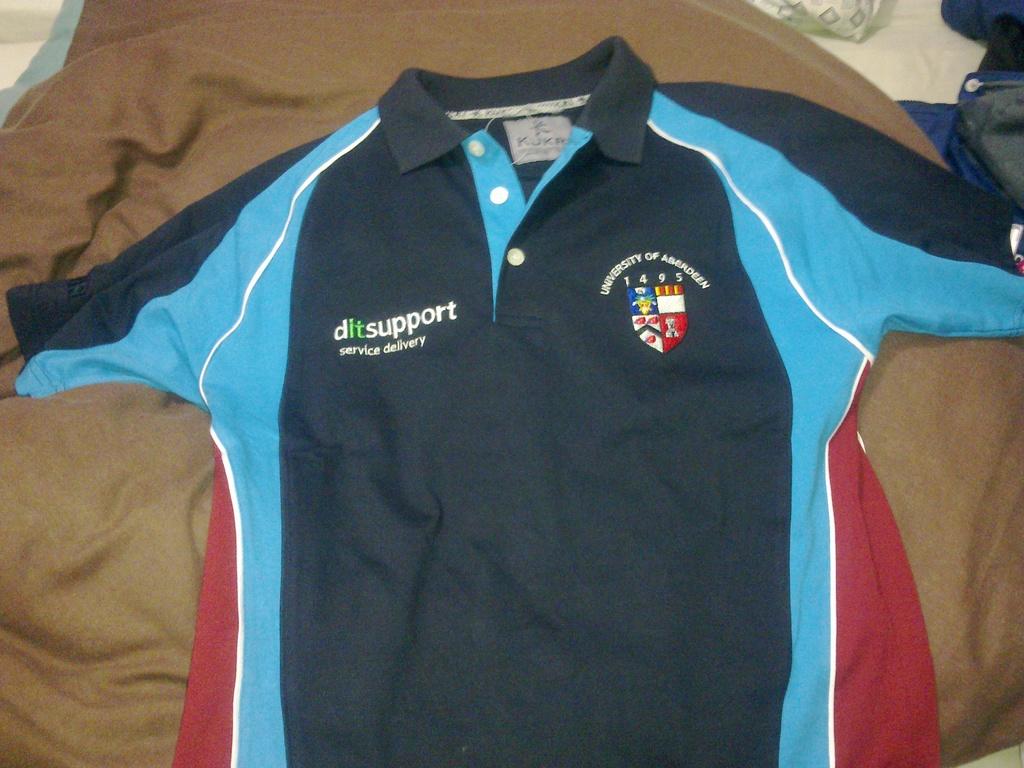When was the university founded?
Make the answer very short. 1495. Where is the brand ditsupport service delivery located?
Provide a short and direct response. University of aberdeen. 